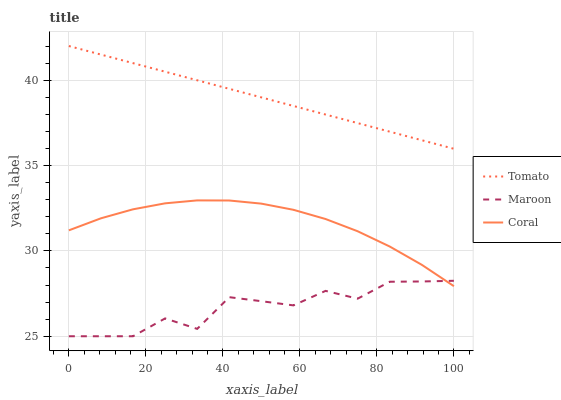Does Maroon have the minimum area under the curve?
Answer yes or no. Yes. Does Tomato have the maximum area under the curve?
Answer yes or no. Yes. Does Coral have the minimum area under the curve?
Answer yes or no. No. Does Coral have the maximum area under the curve?
Answer yes or no. No. Is Tomato the smoothest?
Answer yes or no. Yes. Is Maroon the roughest?
Answer yes or no. Yes. Is Coral the smoothest?
Answer yes or no. No. Is Coral the roughest?
Answer yes or no. No. Does Maroon have the lowest value?
Answer yes or no. Yes. Does Coral have the lowest value?
Answer yes or no. No. Does Tomato have the highest value?
Answer yes or no. Yes. Does Coral have the highest value?
Answer yes or no. No. Is Maroon less than Tomato?
Answer yes or no. Yes. Is Tomato greater than Coral?
Answer yes or no. Yes. Does Coral intersect Maroon?
Answer yes or no. Yes. Is Coral less than Maroon?
Answer yes or no. No. Is Coral greater than Maroon?
Answer yes or no. No. Does Maroon intersect Tomato?
Answer yes or no. No. 